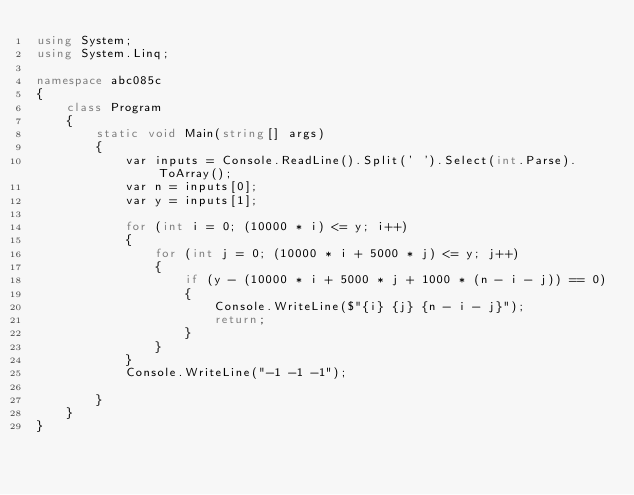Convert code to text. <code><loc_0><loc_0><loc_500><loc_500><_C#_>using System;
using System.Linq;

namespace abc085c
{
    class Program
    {
        static void Main(string[] args)
        {
            var inputs = Console.ReadLine().Split(' ').Select(int.Parse).ToArray();
            var n = inputs[0];
            var y = inputs[1];

            for (int i = 0; (10000 * i) <= y; i++)
            {
                for (int j = 0; (10000 * i + 5000 * j) <= y; j++)
                {
                    if (y - (10000 * i + 5000 * j + 1000 * (n - i - j)) == 0)
                    {
                        Console.WriteLine($"{i} {j} {n - i - j}");
                        return;
                    }
                }
            }
            Console.WriteLine("-1 -1 -1");

        }
    }
}
</code> 